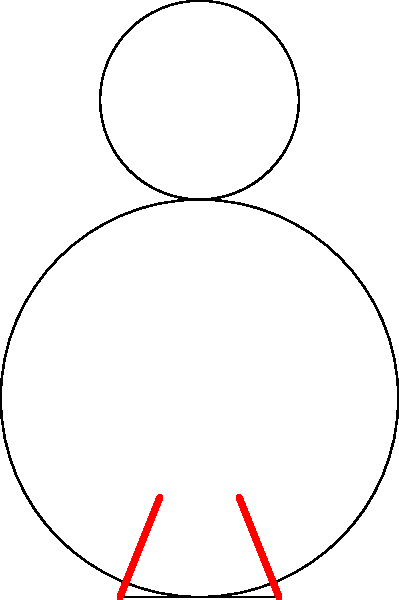In the context of the 1962 FIFA World Cup, consider the biomechanics of heading a football. When a player heads the ball, which pair of neck muscles primarily contracts to stabilize the head and counteract the force of the ball impact? To understand the biomechanics of heading a football, let's break down the process:

1. As the ball approaches, the player prepares to head it by tensing their neck muscles.

2. The primary muscles involved in stabilizing the head during a header are the sternocleidomastoid muscles, which are depicted in red in the diagram.

3. These muscles run from the base of the skull to the sternum and clavicle on each side of the neck.

4. When the ball impacts the forehead (represented by the blue force vector $\vec{F}$ in the diagram), it exerts a backward force on the head.

5. To counteract this force and maintain head stability, the sternocleidomastoid muscles on both sides contract simultaneously.

6. This contraction generates a reaction force (green vector $\vec{R}$ in the diagram) that opposes the ball's impact force.

7. The simultaneous contraction of both left and right sternocleidomastoid muscles is crucial for maintaining head stability and preventing injury.

8. This muscle action allows the player to direct the ball accurately while minimizing the risk of neck strain or concussion.

Understanding this biomechanical process helps explain how players in the 1962 FIFA World Cup, and indeed throughout football history, have been able to effectively use heading techniques in their gameplay.
Answer: Sternocleidomastoid muscles 